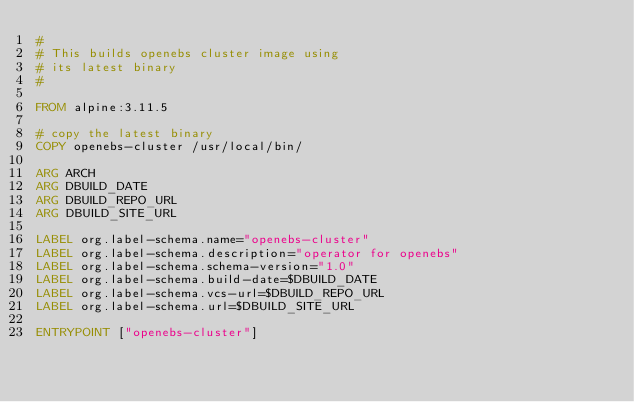Convert code to text. <code><loc_0><loc_0><loc_500><loc_500><_Dockerfile_>#
# This builds openebs cluster image using 
# its latest binary
#

FROM alpine:3.11.5

# copy the latest binary
COPY openebs-cluster /usr/local/bin/

ARG ARCH
ARG DBUILD_DATE
ARG DBUILD_REPO_URL
ARG DBUILD_SITE_URL

LABEL org.label-schema.name="openebs-cluster"
LABEL org.label-schema.description="operator for openebs"
LABEL org.label-schema.schema-version="1.0"
LABEL org.label-schema.build-date=$DBUILD_DATE
LABEL org.label-schema.vcs-url=$DBUILD_REPO_URL
LABEL org.label-schema.url=$DBUILD_SITE_URL

ENTRYPOINT ["openebs-cluster"]
</code> 